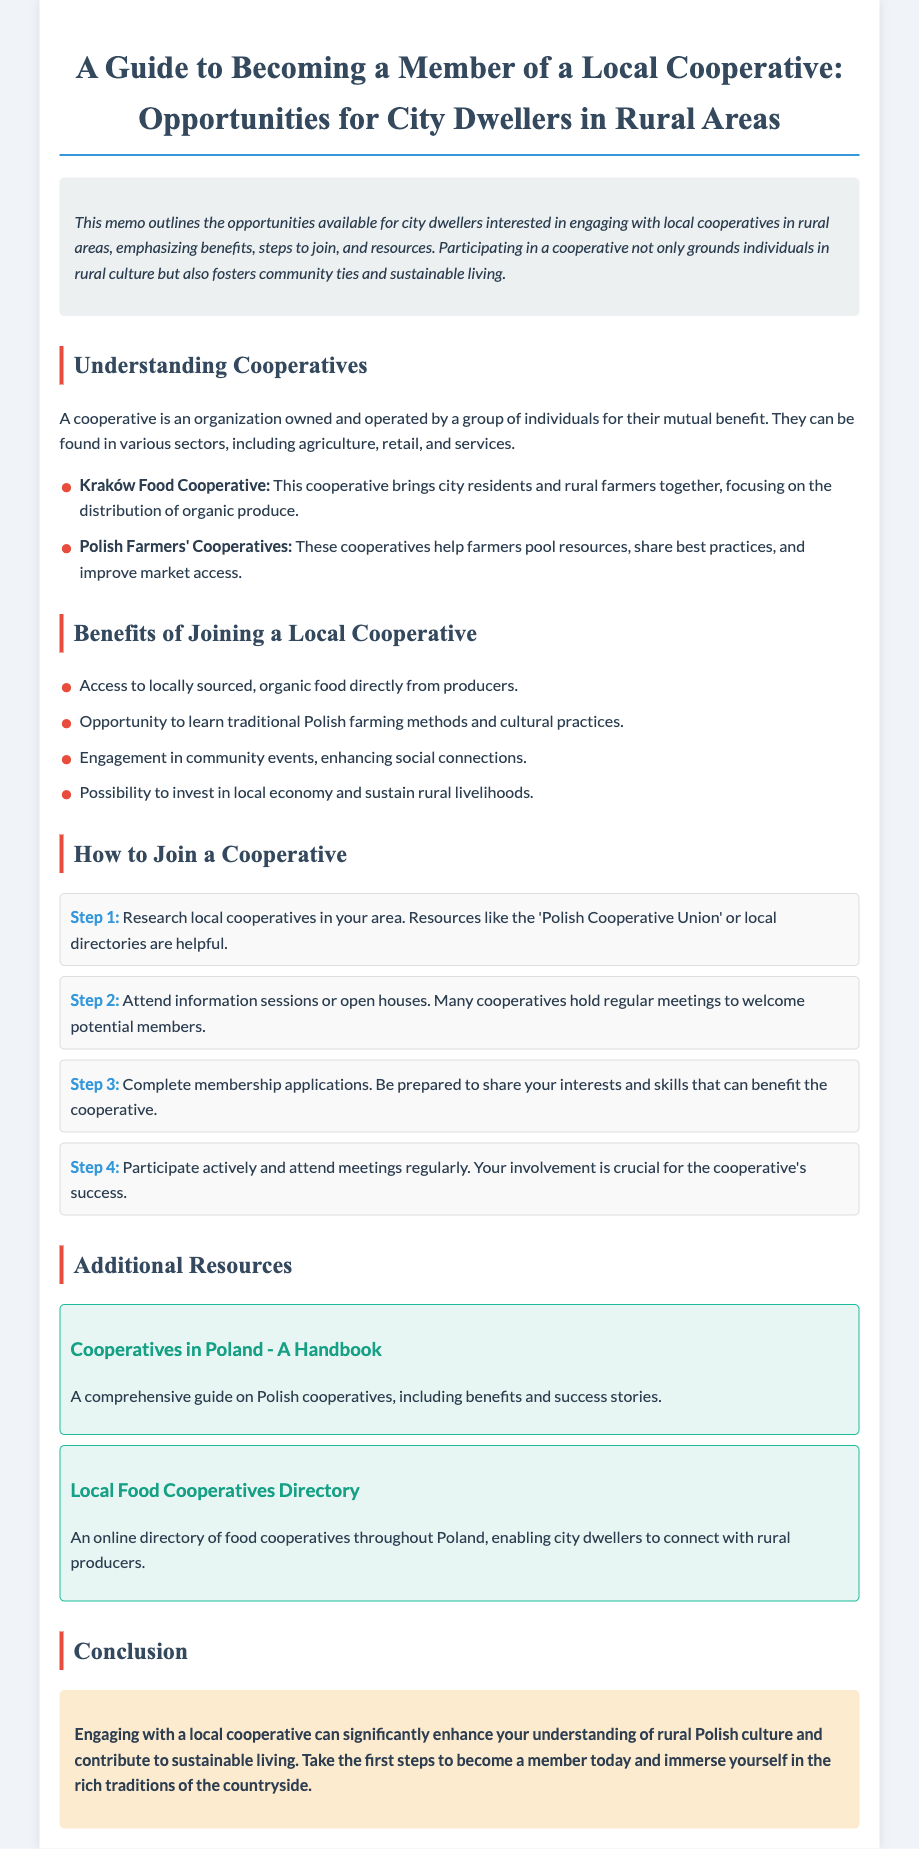What is a cooperative? A cooperative is defined in the document as an organization owned and operated by a group of individuals for their mutual benefit.
Answer: Organization owned and operated by individuals What is the focus of the Kraków Food Cooperative? The focus of the Kraków Food Cooperative is detailed in the document, highlighting its role in bringing together city residents and rural farmers for organic produce distribution.
Answer: Distribution of organic produce How many steps are listed for joining a cooperative? The document outlines a total of four steps necessary for joining a cooperative.
Answer: Four steps What can members learn by joining a cooperative? The benefits list includes the opportunity to learn traditional Polish farming methods and cultural practices as a benefit of joining a cooperative.
Answer: Traditional Polish farming methods Which organization offers a handbook on cooperatives in Poland? The document mentions the 'Cooperatives in Poland - A Handbook' as a resource linked therein that provides comprehensive information.
Answer: Polish Cooperative Union What type of events can members engage in by joining a cooperative? Members can participate in community events, which are mentioned as a benefit in the document for social connection improvement.
Answer: Community events What color is used for the header of the document? The design style elements state that the color used for the header is #34495e according to the CSS styles outlined.
Answer: #34495e What is mentioned as a crucial aspect for the success of a cooperative? The document emphasizes the importance of participation and regular meeting attendance as crucial to the success of a cooperative.
Answer: Active participation 